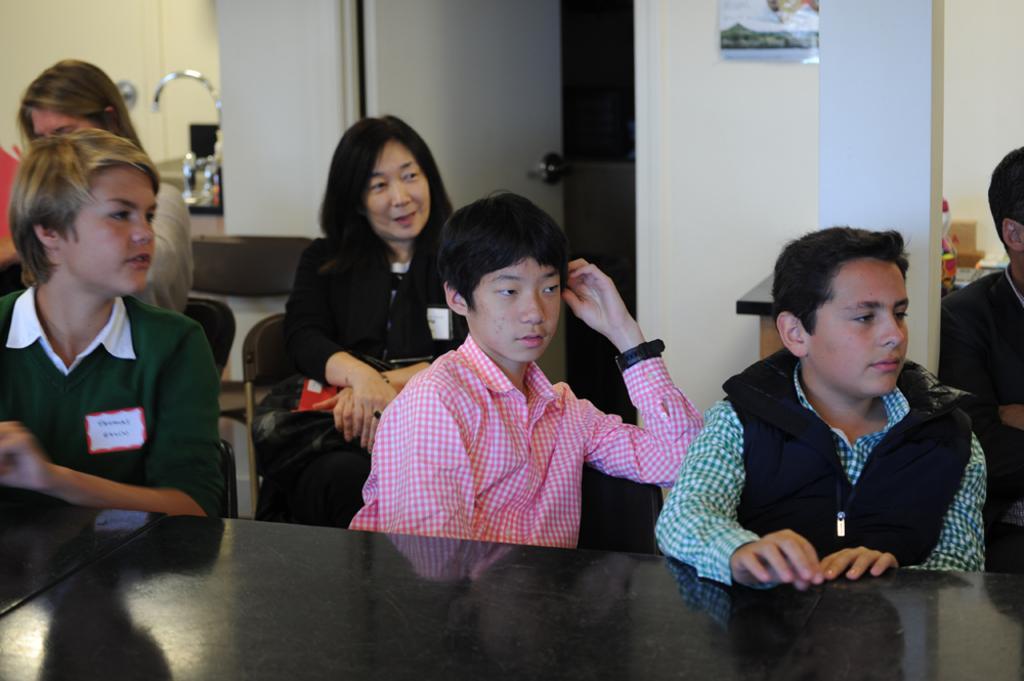In one or two sentences, can you explain what this image depicts? In this image we can see persons sitting on the chairs. At the bottom of the image there is table. In The background we can see door, sink, tap, pillar and wall. 